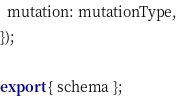Convert code to text. <code><loc_0><loc_0><loc_500><loc_500><_JavaScript_>  mutation: mutationType,
});

export { schema };
</code> 